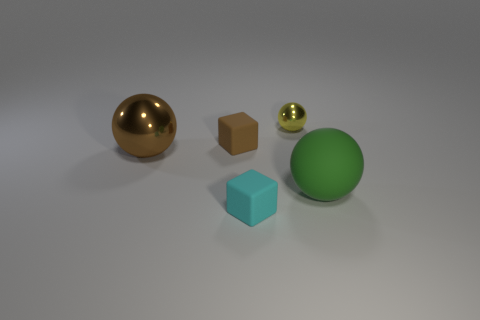There is a tiny block right of the small matte block behind the small cyan rubber cube; what number of yellow spheres are behind it?
Keep it short and to the point. 1. What number of small objects are behind the small cyan object and on the right side of the tiny brown matte cube?
Ensure brevity in your answer.  1. Are there more big matte things to the left of the small cyan rubber block than green things?
Make the answer very short. No. How many brown rubber cubes are the same size as the yellow ball?
Offer a terse response. 1. What is the size of the rubber thing that is the same color as the big metal thing?
Give a very brief answer. Small. What number of tiny things are blue matte things or green spheres?
Your response must be concise. 0. How many green spheres are there?
Your answer should be compact. 1. Is the number of tiny cyan things left of the brown rubber thing the same as the number of small shiny balls that are behind the yellow object?
Your answer should be very brief. Yes. Are there any big green objects left of the brown sphere?
Keep it short and to the point. No. What is the color of the cube that is in front of the green matte object?
Your answer should be very brief. Cyan. 